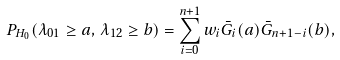<formula> <loc_0><loc_0><loc_500><loc_500>P _ { H _ { 0 } } ( \lambda _ { 0 1 } \geq a , \, \lambda _ { 1 2 } \geq b ) = \sum _ { i = 0 } ^ { n + 1 } w _ { i } \bar { G } _ { i } ( a ) \bar { G } _ { n + 1 - i } ( b ) ,</formula> 